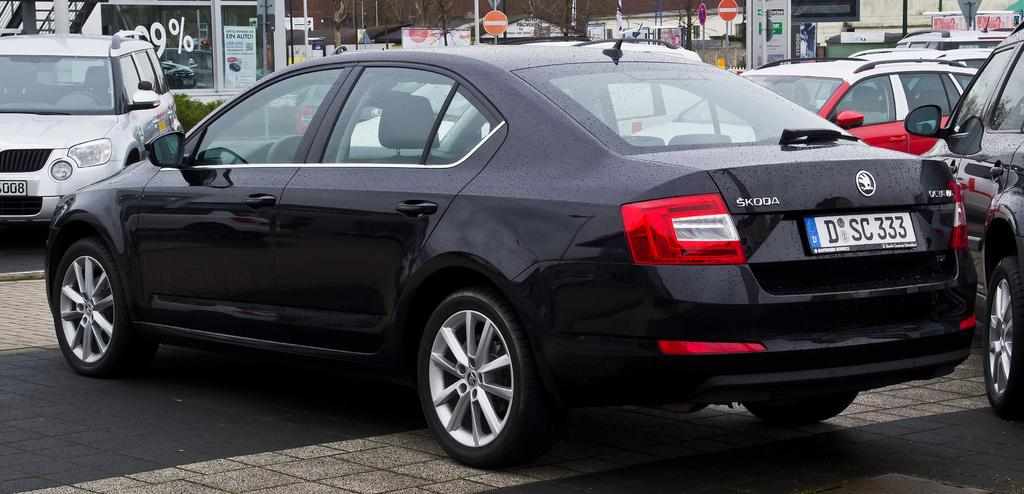What color is the car that is visible on the road in the image? The car on the road is black. What else can be seen on the road in the image? There are no other objects or vehicles visible on the road in the image. What can be seen in the background of the image? In the background of the image, there are cars, trees, and sign board poles. How much sugar is in the car's gas tank in the image? There is no information about sugar or the car's gas tank in the image, as it only shows a black car on the road and objects in the background. 